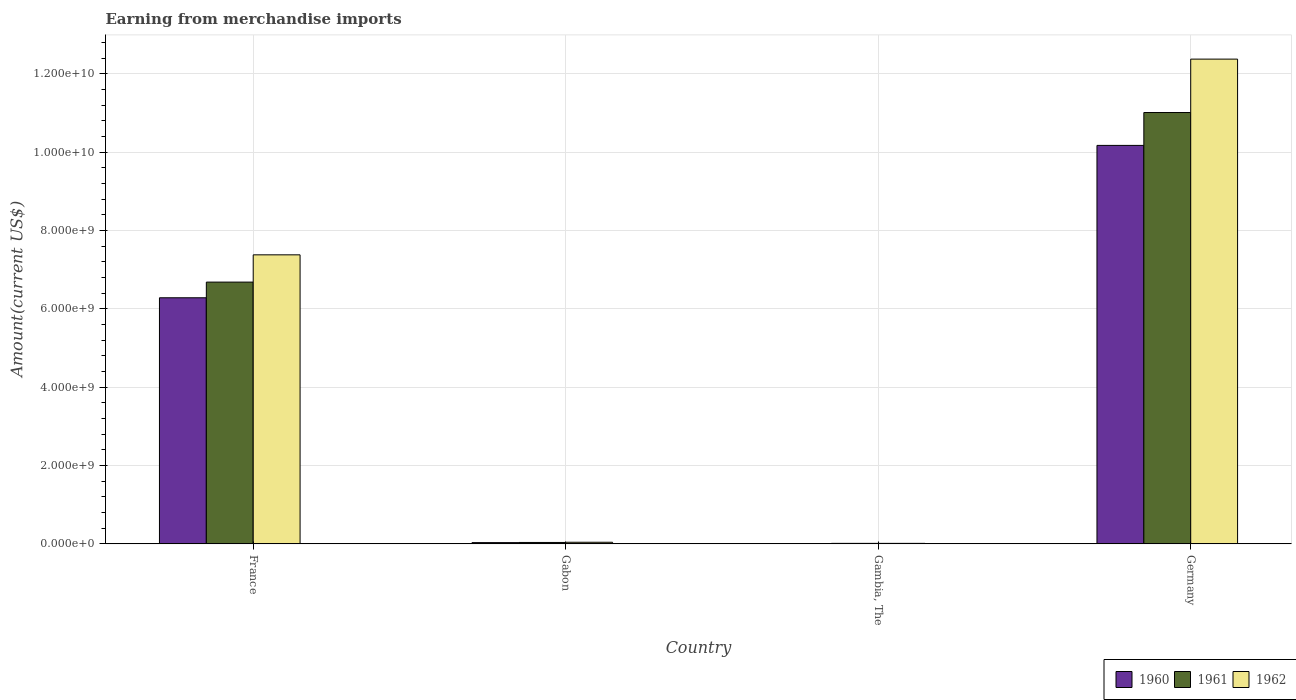How many groups of bars are there?
Ensure brevity in your answer.  4. Are the number of bars per tick equal to the number of legend labels?
Provide a succinct answer. Yes. How many bars are there on the 3rd tick from the right?
Keep it short and to the point. 3. What is the label of the 2nd group of bars from the left?
Give a very brief answer. Gabon. What is the amount earned from merchandise imports in 1962 in Gabon?
Make the answer very short. 4.08e+07. Across all countries, what is the maximum amount earned from merchandise imports in 1961?
Provide a short and direct response. 1.10e+1. Across all countries, what is the minimum amount earned from merchandise imports in 1960?
Offer a terse response. 9.02e+06. In which country was the amount earned from merchandise imports in 1962 maximum?
Offer a very short reply. Germany. In which country was the amount earned from merchandise imports in 1961 minimum?
Give a very brief answer. Gambia, The. What is the total amount earned from merchandise imports in 1962 in the graph?
Provide a short and direct response. 1.98e+1. What is the difference between the amount earned from merchandise imports in 1961 in Gabon and that in Gambia, The?
Your answer should be compact. 2.30e+07. What is the difference between the amount earned from merchandise imports in 1960 in Gabon and the amount earned from merchandise imports in 1961 in France?
Ensure brevity in your answer.  -6.65e+09. What is the average amount earned from merchandise imports in 1960 per country?
Provide a short and direct response. 4.12e+09. What is the difference between the amount earned from merchandise imports of/in 1962 and amount earned from merchandise imports of/in 1961 in Gambia, The?
Offer a very short reply. -2.52e+05. What is the ratio of the amount earned from merchandise imports in 1960 in France to that in Germany?
Provide a short and direct response. 0.62. Is the difference between the amount earned from merchandise imports in 1962 in Gambia, The and Germany greater than the difference between the amount earned from merchandise imports in 1961 in Gambia, The and Germany?
Make the answer very short. No. What is the difference between the highest and the second highest amount earned from merchandise imports in 1960?
Make the answer very short. 3.89e+09. What is the difference between the highest and the lowest amount earned from merchandise imports in 1960?
Your answer should be very brief. 1.02e+1. In how many countries, is the amount earned from merchandise imports in 1960 greater than the average amount earned from merchandise imports in 1960 taken over all countries?
Ensure brevity in your answer.  2. Is the sum of the amount earned from merchandise imports in 1962 in Gabon and Germany greater than the maximum amount earned from merchandise imports in 1960 across all countries?
Give a very brief answer. Yes. What does the 3rd bar from the left in Gabon represents?
Your answer should be compact. 1962. Are the values on the major ticks of Y-axis written in scientific E-notation?
Keep it short and to the point. Yes. How many legend labels are there?
Your response must be concise. 3. What is the title of the graph?
Give a very brief answer. Earning from merchandise imports. Does "1996" appear as one of the legend labels in the graph?
Ensure brevity in your answer.  No. What is the label or title of the X-axis?
Offer a terse response. Country. What is the label or title of the Y-axis?
Provide a succinct answer. Amount(current US$). What is the Amount(current US$) of 1960 in France?
Provide a succinct answer. 6.28e+09. What is the Amount(current US$) of 1961 in France?
Your answer should be compact. 6.68e+09. What is the Amount(current US$) in 1962 in France?
Offer a terse response. 7.38e+09. What is the Amount(current US$) in 1960 in Gabon?
Your response must be concise. 3.17e+07. What is the Amount(current US$) in 1961 in Gabon?
Give a very brief answer. 3.59e+07. What is the Amount(current US$) in 1962 in Gabon?
Your answer should be very brief. 4.08e+07. What is the Amount(current US$) in 1960 in Gambia, The?
Offer a very short reply. 9.02e+06. What is the Amount(current US$) in 1961 in Gambia, The?
Offer a very short reply. 1.28e+07. What is the Amount(current US$) in 1962 in Gambia, The?
Your answer should be very brief. 1.25e+07. What is the Amount(current US$) of 1960 in Germany?
Ensure brevity in your answer.  1.02e+1. What is the Amount(current US$) in 1961 in Germany?
Your answer should be very brief. 1.10e+1. What is the Amount(current US$) of 1962 in Germany?
Your answer should be compact. 1.24e+1. Across all countries, what is the maximum Amount(current US$) in 1960?
Provide a succinct answer. 1.02e+1. Across all countries, what is the maximum Amount(current US$) in 1961?
Provide a succinct answer. 1.10e+1. Across all countries, what is the maximum Amount(current US$) in 1962?
Provide a short and direct response. 1.24e+1. Across all countries, what is the minimum Amount(current US$) of 1960?
Ensure brevity in your answer.  9.02e+06. Across all countries, what is the minimum Amount(current US$) of 1961?
Your answer should be compact. 1.28e+07. Across all countries, what is the minimum Amount(current US$) in 1962?
Your response must be concise. 1.25e+07. What is the total Amount(current US$) of 1960 in the graph?
Offer a terse response. 1.65e+1. What is the total Amount(current US$) in 1961 in the graph?
Ensure brevity in your answer.  1.77e+1. What is the total Amount(current US$) in 1962 in the graph?
Your response must be concise. 1.98e+1. What is the difference between the Amount(current US$) of 1960 in France and that in Gabon?
Give a very brief answer. 6.25e+09. What is the difference between the Amount(current US$) in 1961 in France and that in Gabon?
Your response must be concise. 6.65e+09. What is the difference between the Amount(current US$) in 1962 in France and that in Gabon?
Make the answer very short. 7.34e+09. What is the difference between the Amount(current US$) of 1960 in France and that in Gambia, The?
Keep it short and to the point. 6.27e+09. What is the difference between the Amount(current US$) of 1961 in France and that in Gambia, The?
Keep it short and to the point. 6.67e+09. What is the difference between the Amount(current US$) of 1962 in France and that in Gambia, The?
Your answer should be compact. 7.37e+09. What is the difference between the Amount(current US$) of 1960 in France and that in Germany?
Provide a short and direct response. -3.89e+09. What is the difference between the Amount(current US$) in 1961 in France and that in Germany?
Offer a very short reply. -4.33e+09. What is the difference between the Amount(current US$) of 1962 in France and that in Germany?
Your answer should be very brief. -5.00e+09. What is the difference between the Amount(current US$) of 1960 in Gabon and that in Gambia, The?
Offer a very short reply. 2.27e+07. What is the difference between the Amount(current US$) of 1961 in Gabon and that in Gambia, The?
Your answer should be very brief. 2.30e+07. What is the difference between the Amount(current US$) in 1962 in Gabon and that in Gambia, The?
Offer a terse response. 2.82e+07. What is the difference between the Amount(current US$) in 1960 in Gabon and that in Germany?
Make the answer very short. -1.01e+1. What is the difference between the Amount(current US$) of 1961 in Gabon and that in Germany?
Keep it short and to the point. -1.10e+1. What is the difference between the Amount(current US$) of 1962 in Gabon and that in Germany?
Provide a short and direct response. -1.23e+1. What is the difference between the Amount(current US$) of 1960 in Gambia, The and that in Germany?
Give a very brief answer. -1.02e+1. What is the difference between the Amount(current US$) in 1961 in Gambia, The and that in Germany?
Your answer should be compact. -1.10e+1. What is the difference between the Amount(current US$) of 1962 in Gambia, The and that in Germany?
Keep it short and to the point. -1.24e+1. What is the difference between the Amount(current US$) of 1960 in France and the Amount(current US$) of 1961 in Gabon?
Your response must be concise. 6.25e+09. What is the difference between the Amount(current US$) in 1960 in France and the Amount(current US$) in 1962 in Gabon?
Your response must be concise. 6.24e+09. What is the difference between the Amount(current US$) in 1961 in France and the Amount(current US$) in 1962 in Gabon?
Your answer should be very brief. 6.64e+09. What is the difference between the Amount(current US$) in 1960 in France and the Amount(current US$) in 1961 in Gambia, The?
Give a very brief answer. 6.27e+09. What is the difference between the Amount(current US$) in 1960 in France and the Amount(current US$) in 1962 in Gambia, The?
Your answer should be very brief. 6.27e+09. What is the difference between the Amount(current US$) of 1961 in France and the Amount(current US$) of 1962 in Gambia, The?
Your answer should be compact. 6.67e+09. What is the difference between the Amount(current US$) in 1960 in France and the Amount(current US$) in 1961 in Germany?
Make the answer very short. -4.73e+09. What is the difference between the Amount(current US$) of 1960 in France and the Amount(current US$) of 1962 in Germany?
Your response must be concise. -6.09e+09. What is the difference between the Amount(current US$) in 1961 in France and the Amount(current US$) in 1962 in Germany?
Your answer should be compact. -5.69e+09. What is the difference between the Amount(current US$) in 1960 in Gabon and the Amount(current US$) in 1961 in Gambia, The?
Give a very brief answer. 1.89e+07. What is the difference between the Amount(current US$) of 1960 in Gabon and the Amount(current US$) of 1962 in Gambia, The?
Make the answer very short. 1.92e+07. What is the difference between the Amount(current US$) in 1961 in Gabon and the Amount(current US$) in 1962 in Gambia, The?
Your answer should be compact. 2.33e+07. What is the difference between the Amount(current US$) in 1960 in Gabon and the Amount(current US$) in 1961 in Germany?
Your answer should be very brief. -1.10e+1. What is the difference between the Amount(current US$) of 1960 in Gabon and the Amount(current US$) of 1962 in Germany?
Provide a short and direct response. -1.23e+1. What is the difference between the Amount(current US$) in 1961 in Gabon and the Amount(current US$) in 1962 in Germany?
Provide a succinct answer. -1.23e+1. What is the difference between the Amount(current US$) in 1960 in Gambia, The and the Amount(current US$) in 1961 in Germany?
Offer a very short reply. -1.10e+1. What is the difference between the Amount(current US$) in 1960 in Gambia, The and the Amount(current US$) in 1962 in Germany?
Make the answer very short. -1.24e+1. What is the difference between the Amount(current US$) of 1961 in Gambia, The and the Amount(current US$) of 1962 in Germany?
Your response must be concise. -1.24e+1. What is the average Amount(current US$) of 1960 per country?
Give a very brief answer. 4.12e+09. What is the average Amount(current US$) in 1961 per country?
Your answer should be very brief. 4.44e+09. What is the average Amount(current US$) of 1962 per country?
Your answer should be very brief. 4.95e+09. What is the difference between the Amount(current US$) in 1960 and Amount(current US$) in 1961 in France?
Offer a terse response. -4.00e+08. What is the difference between the Amount(current US$) of 1960 and Amount(current US$) of 1962 in France?
Your response must be concise. -1.10e+09. What is the difference between the Amount(current US$) of 1961 and Amount(current US$) of 1962 in France?
Offer a very short reply. -6.96e+08. What is the difference between the Amount(current US$) of 1960 and Amount(current US$) of 1961 in Gabon?
Provide a succinct answer. -4.13e+06. What is the difference between the Amount(current US$) of 1960 and Amount(current US$) of 1962 in Gabon?
Offer a very short reply. -9.07e+06. What is the difference between the Amount(current US$) of 1961 and Amount(current US$) of 1962 in Gabon?
Make the answer very short. -4.94e+06. What is the difference between the Amount(current US$) of 1960 and Amount(current US$) of 1961 in Gambia, The?
Provide a succinct answer. -3.78e+06. What is the difference between the Amount(current US$) of 1960 and Amount(current US$) of 1962 in Gambia, The?
Make the answer very short. -3.53e+06. What is the difference between the Amount(current US$) of 1961 and Amount(current US$) of 1962 in Gambia, The?
Ensure brevity in your answer.  2.52e+05. What is the difference between the Amount(current US$) of 1960 and Amount(current US$) of 1961 in Germany?
Your answer should be very brief. -8.39e+08. What is the difference between the Amount(current US$) of 1960 and Amount(current US$) of 1962 in Germany?
Offer a terse response. -2.20e+09. What is the difference between the Amount(current US$) of 1961 and Amount(current US$) of 1962 in Germany?
Your response must be concise. -1.36e+09. What is the ratio of the Amount(current US$) of 1960 in France to that in Gabon?
Ensure brevity in your answer.  198.06. What is the ratio of the Amount(current US$) of 1961 in France to that in Gabon?
Make the answer very short. 186.4. What is the ratio of the Amount(current US$) of 1962 in France to that in Gabon?
Provide a succinct answer. 180.87. What is the ratio of the Amount(current US$) in 1960 in France to that in Gambia, The?
Provide a succinct answer. 696.36. What is the ratio of the Amount(current US$) of 1961 in France to that in Gambia, The?
Your answer should be very brief. 522.01. What is the ratio of the Amount(current US$) of 1962 in France to that in Gambia, The?
Offer a terse response. 587.95. What is the ratio of the Amount(current US$) in 1960 in France to that in Germany?
Keep it short and to the point. 0.62. What is the ratio of the Amount(current US$) of 1961 in France to that in Germany?
Your response must be concise. 0.61. What is the ratio of the Amount(current US$) of 1962 in France to that in Germany?
Ensure brevity in your answer.  0.6. What is the ratio of the Amount(current US$) in 1960 in Gabon to that in Gambia, The?
Keep it short and to the point. 3.52. What is the ratio of the Amount(current US$) in 1961 in Gabon to that in Gambia, The?
Give a very brief answer. 2.8. What is the ratio of the Amount(current US$) of 1962 in Gabon to that in Gambia, The?
Provide a succinct answer. 3.25. What is the ratio of the Amount(current US$) in 1960 in Gabon to that in Germany?
Provide a short and direct response. 0. What is the ratio of the Amount(current US$) in 1961 in Gabon to that in Germany?
Make the answer very short. 0. What is the ratio of the Amount(current US$) in 1962 in Gabon to that in Germany?
Ensure brevity in your answer.  0. What is the ratio of the Amount(current US$) of 1960 in Gambia, The to that in Germany?
Your answer should be compact. 0. What is the ratio of the Amount(current US$) of 1961 in Gambia, The to that in Germany?
Offer a very short reply. 0. What is the ratio of the Amount(current US$) of 1962 in Gambia, The to that in Germany?
Your answer should be compact. 0. What is the difference between the highest and the second highest Amount(current US$) in 1960?
Give a very brief answer. 3.89e+09. What is the difference between the highest and the second highest Amount(current US$) of 1961?
Ensure brevity in your answer.  4.33e+09. What is the difference between the highest and the second highest Amount(current US$) of 1962?
Your response must be concise. 5.00e+09. What is the difference between the highest and the lowest Amount(current US$) in 1960?
Give a very brief answer. 1.02e+1. What is the difference between the highest and the lowest Amount(current US$) of 1961?
Your answer should be compact. 1.10e+1. What is the difference between the highest and the lowest Amount(current US$) in 1962?
Give a very brief answer. 1.24e+1. 